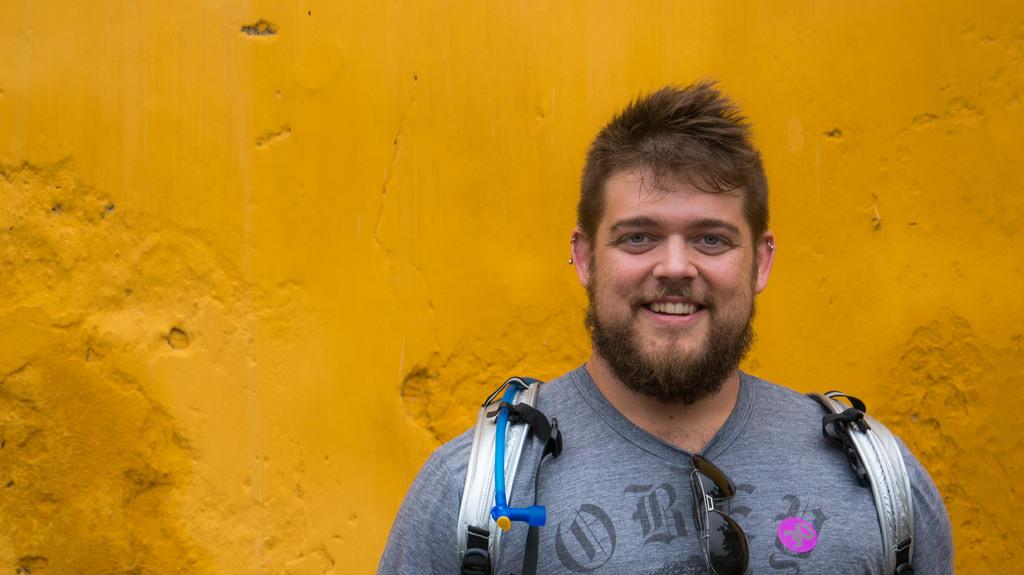What is the main subject in the foreground of the image? There is a man in the foreground of the image. What is the man doing in the image? The man is standing in the image. What is the man's facial expression in the image? The man is smiling in the image. What can be seen in the background of the image? There is a wall in the background of the image. Where is the playground located in the image? There is no playground present in the image. What type of whip is the man holding in the image? The man is not holding any whip in the image. 